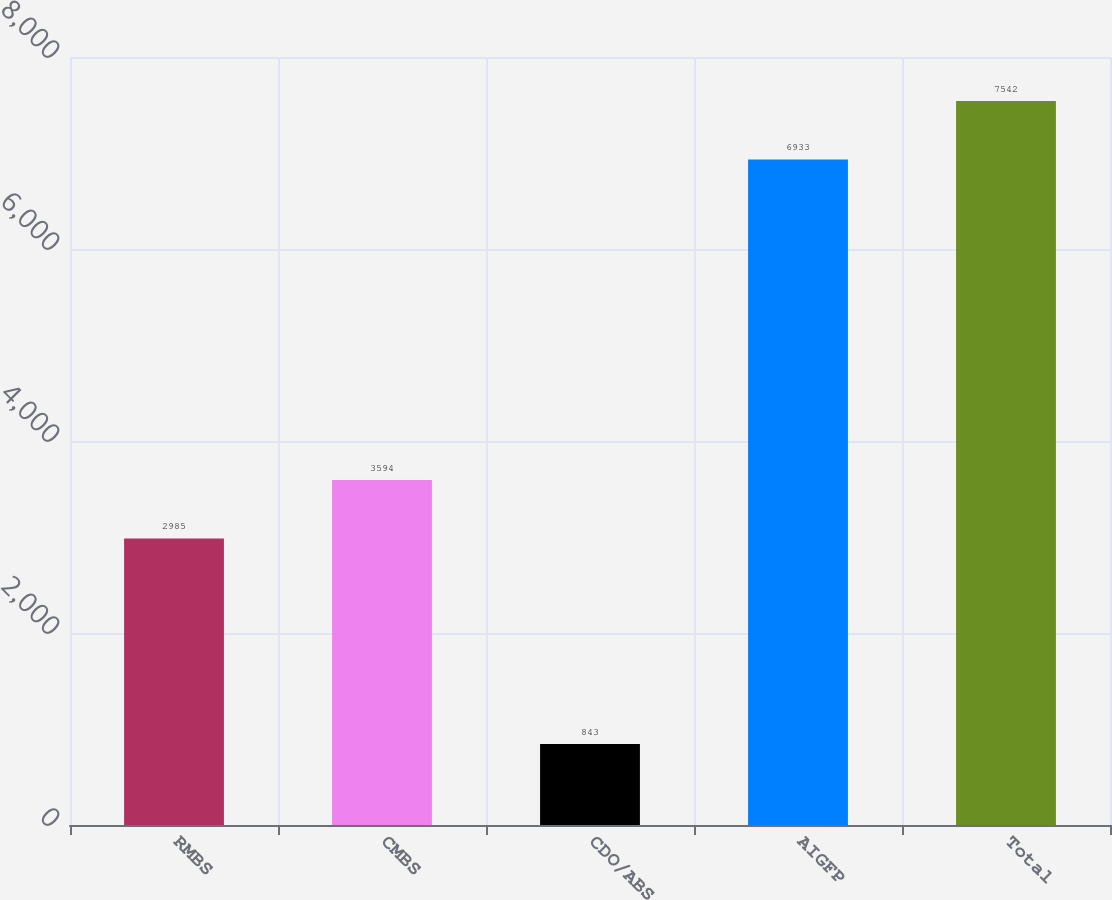Convert chart. <chart><loc_0><loc_0><loc_500><loc_500><bar_chart><fcel>RMBS<fcel>CMBS<fcel>CDO/ABS<fcel>AIGFP<fcel>Total<nl><fcel>2985<fcel>3594<fcel>843<fcel>6933<fcel>7542<nl></chart> 